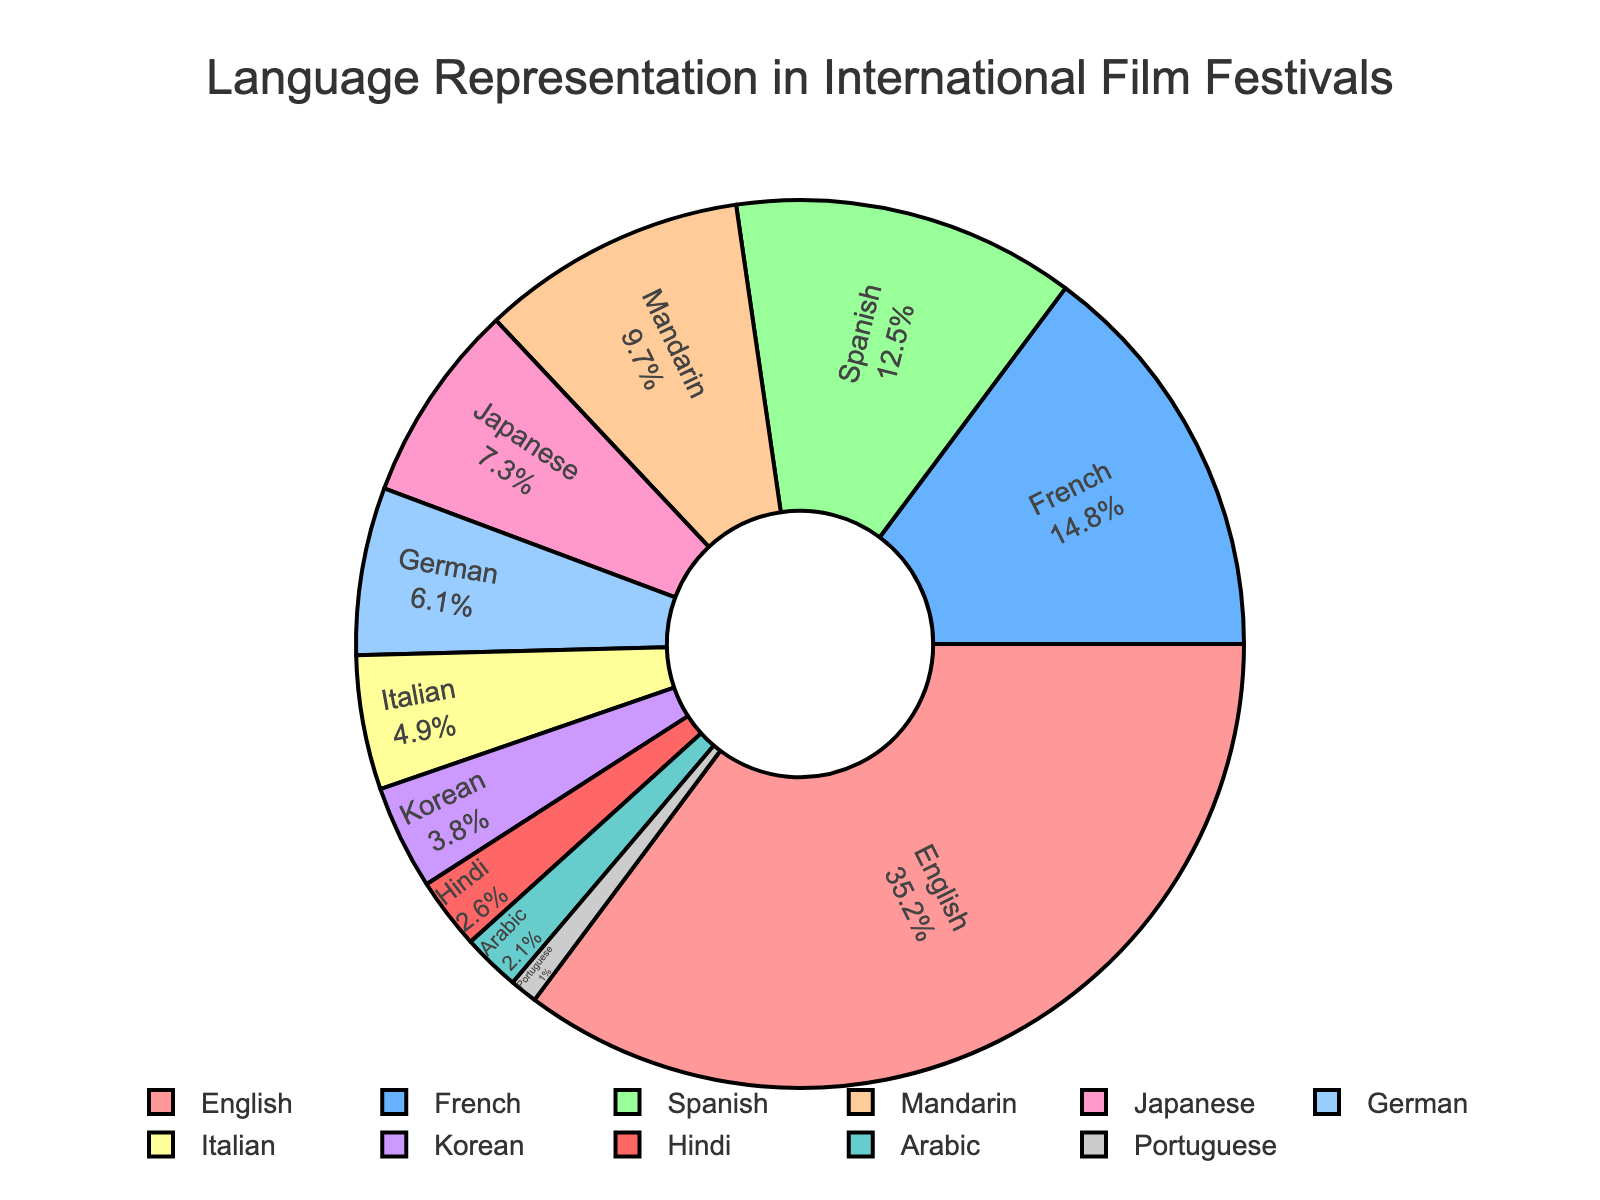What percentage of languages are represented by European languages (English, French, Spanish, German, and Italian)? Sum the percentages of the European languages: English (35.2%) + French (14.8%) + Spanish (12.5%) + German (6.1%) + Italian (4.9%) = 73.5%
Answer: 73.5% Which language has the smallest representation in international film festivals? The language with the smallest percentage value in the pie chart is Portuguese, with 1.0%.
Answer: Portuguese How does the representation of Mandarin compare to that of Japanese? Mandarin has a representation of 9.7%, while Japanese has a representation of 7.3%. Since 9.7% > 7.3%, Mandarin has a higher representation than Japanese.
Answer: Mandarin What's the combined percentage of languages with less than 5% representation? Sum the percentages of languages with less than 5%: Italian (4.9%) + Korean (3.8%) + Hindi (2.6%) + Arabic (2.1%) + Portuguese (1.0%) = 14.4%
Answer: 14.4% Are there more films represented in French or Spanish at international film festivals? Comparing the percentages, French (14.8%) is greater than Spanish (12.5%).
Answer: French What is the difference between the highest and the lowest language representation percentages? Subtract the smallest percentage (Portuguese with 1.0%) from the largest percentage (English with 35.2%): 35.2% - 1.0% = 34.2%
Answer: 34.2% If the film festival decides to feature exactly three more languages, which current top three languages should they prioritize based on representation? The top three languages based on current percentages are English (35.2%), French (14.8%), and Spanish (12.5%).
Answer: English, French, Spanish How many languages represent more than 10% of films at the international film festivals? Count the languages with more than 10% representation: English (35.2%), French (14.8%), and Spanish (12.5%), which totals to 3 languages.
Answer: 3 What is the average representation percentage of the Asian languages (Mandarin, Japanese, Korean, Hindi)? Sum the percentages: Mandarin (9.7%) + Japanese (7.3%) + Korean (3.8%) + Hindi (2.6%) = 23.4%. Divide by the number of languages (4): 23.4% / 4 = 5.85%.
Answer: 5.85% Determine the visual color for Spanish. Spanish is represented in a pie slice with a specific color. According to the color order, Spanish corresponds to the third color listed, which is green.
Answer: Green 